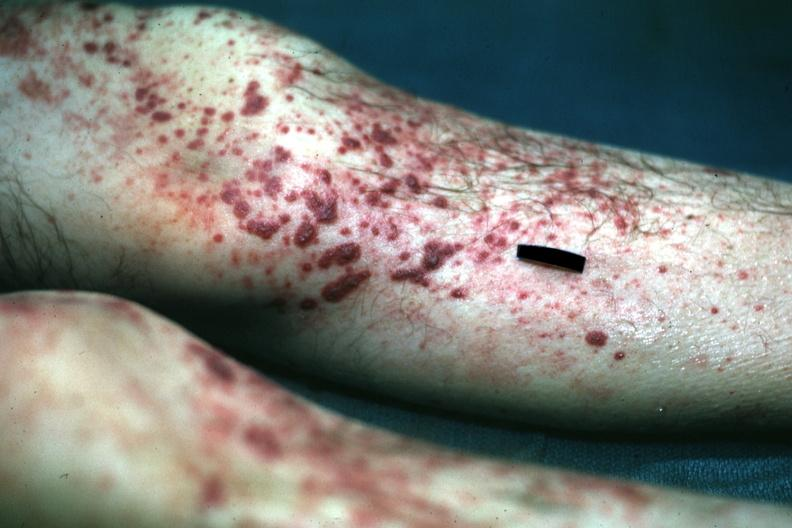what does this image show?
Answer the question using a single word or phrase. Skin over legs quite good 